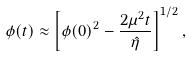Convert formula to latex. <formula><loc_0><loc_0><loc_500><loc_500>\phi ( t ) \approx \left [ \phi ( 0 ) ^ { 2 } - \frac { 2 \mu ^ { 2 } t } { \hat { \eta } } \right ] ^ { 1 / 2 } ,</formula> 